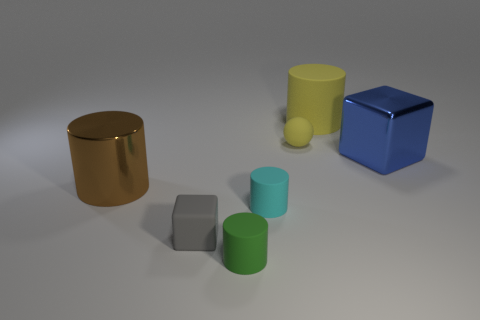There is a matte cylinder that is the same color as the tiny matte sphere; what is its size?
Make the answer very short. Large. Are there any other tiny rubber things of the same shape as the small cyan rubber thing?
Your answer should be very brief. Yes. What material is the large yellow object that is the same shape as the cyan rubber thing?
Provide a succinct answer. Rubber. What is the shape of the big metallic object that is on the left side of the object that is to the right of the rubber cylinder that is behind the big metallic cylinder?
Ensure brevity in your answer.  Cylinder. What number of blue things are either blocks or small spheres?
Your answer should be very brief. 1. How many small gray rubber blocks are left of the shiny thing right of the big shiny cylinder?
Offer a terse response. 1. Is there anything else of the same color as the matte block?
Provide a succinct answer. No. There is a small cyan thing that is made of the same material as the small cube; what is its shape?
Your response must be concise. Cylinder. Do the tiny sphere and the large rubber cylinder have the same color?
Offer a very short reply. Yes. Is the thing right of the large yellow rubber object made of the same material as the large cylinder that is left of the small gray object?
Ensure brevity in your answer.  Yes. 